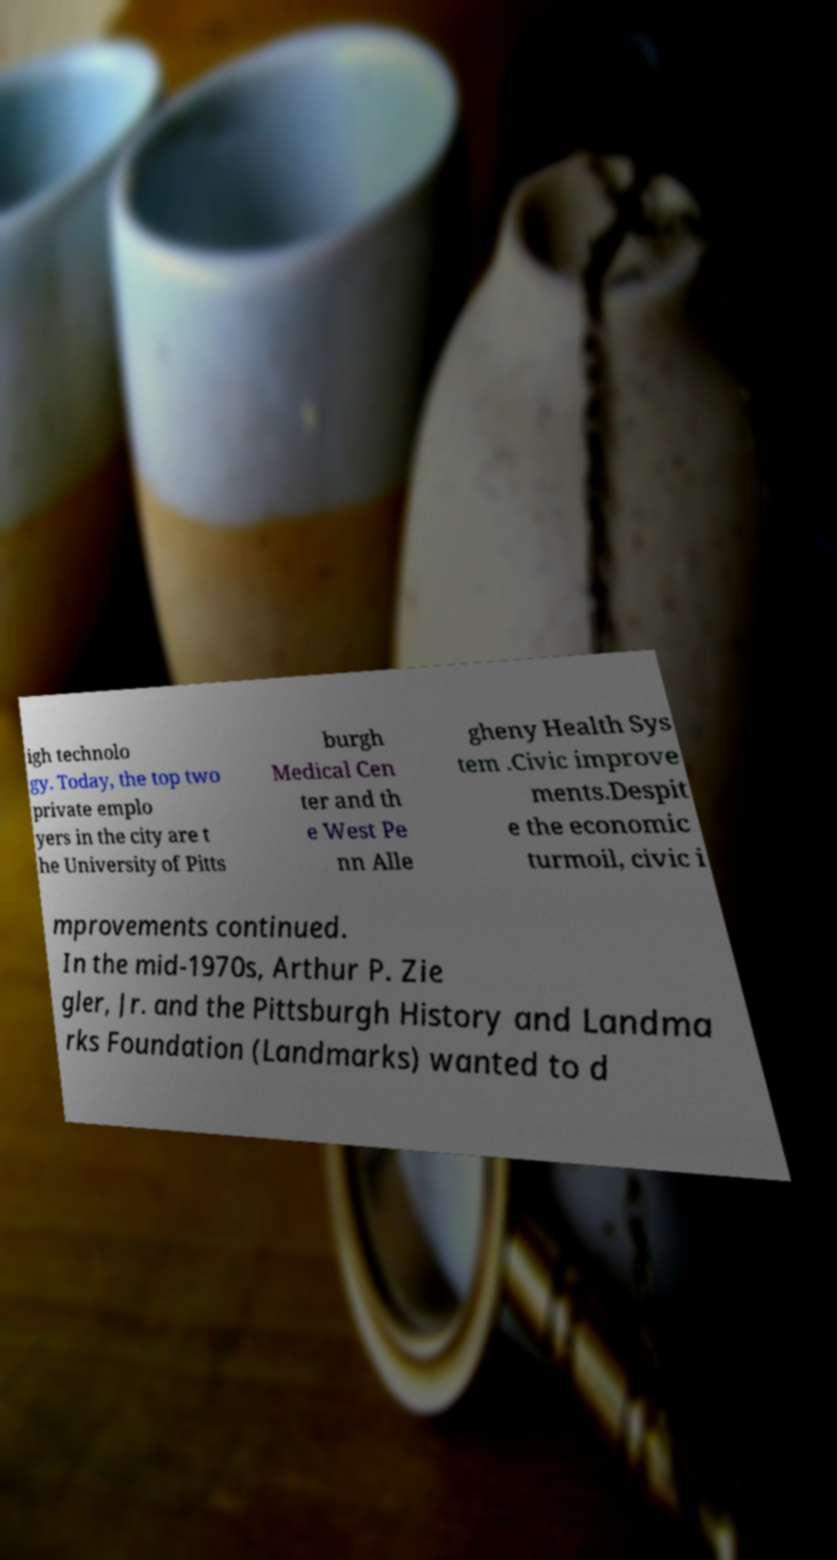Could you extract and type out the text from this image? igh technolo gy. Today, the top two private emplo yers in the city are t he University of Pitts burgh Medical Cen ter and th e West Pe nn Alle gheny Health Sys tem .Civic improve ments.Despit e the economic turmoil, civic i mprovements continued. In the mid-1970s, Arthur P. Zie gler, Jr. and the Pittsburgh History and Landma rks Foundation (Landmarks) wanted to d 